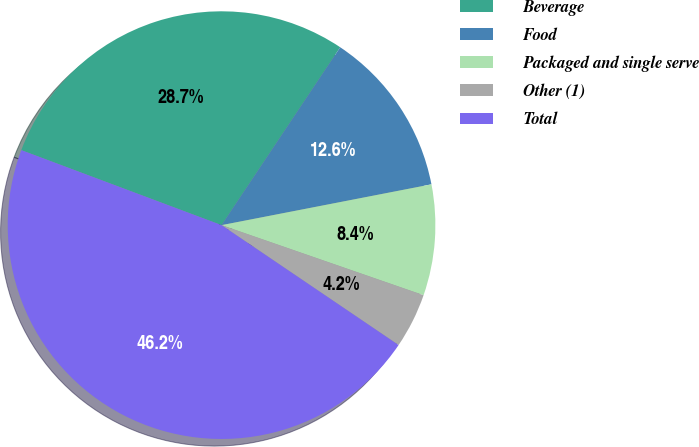Convert chart. <chart><loc_0><loc_0><loc_500><loc_500><pie_chart><fcel>Beverage<fcel>Food<fcel>Packaged and single serve<fcel>Other (1)<fcel>Total<nl><fcel>28.66%<fcel>12.58%<fcel>8.37%<fcel>4.16%<fcel>46.23%<nl></chart> 